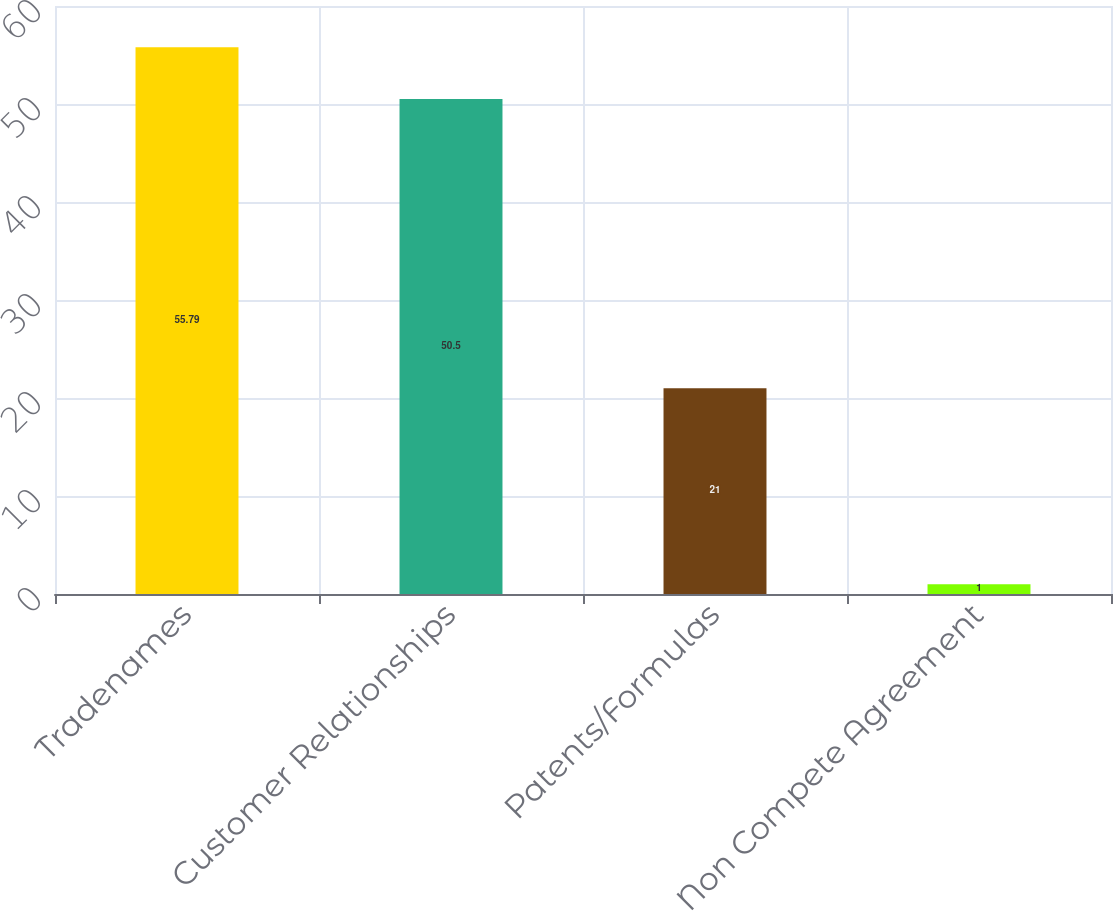Convert chart. <chart><loc_0><loc_0><loc_500><loc_500><bar_chart><fcel>Tradenames<fcel>Customer Relationships<fcel>Patents/Formulas<fcel>Non Compete Agreement<nl><fcel>55.79<fcel>50.5<fcel>21<fcel>1<nl></chart> 